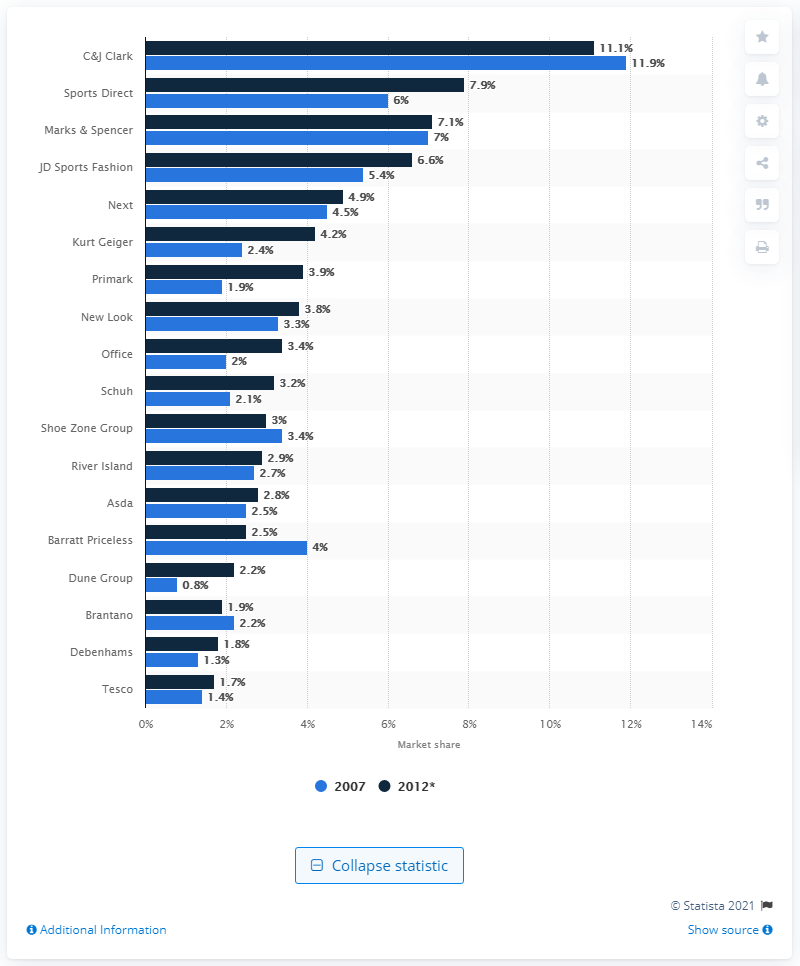Outline some significant characteristics in this image. C&J Clark was the leading shoe retailer in the UK from 2007 to 2012, holding the largest share of the footwear market during this time period. In 2012, Sports Direct was the second largest footwear retailer in the United Kingdom. 